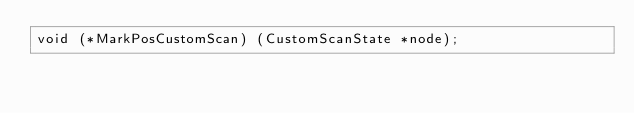<code> <loc_0><loc_0><loc_500><loc_500><_SQL_>void (*MarkPosCustomScan) (CustomScanState *node);
</code> 